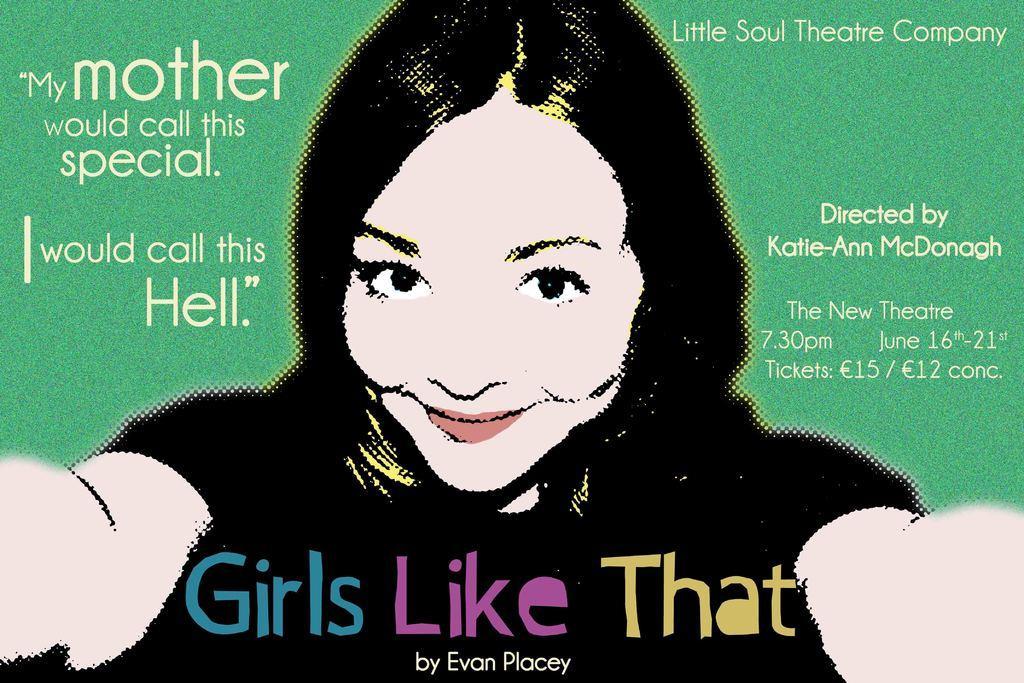Describe this image in one or two sentences. In this image, we can see a poster. Here we can see a woman is seeing and smiling. Here we can see text in the image. 